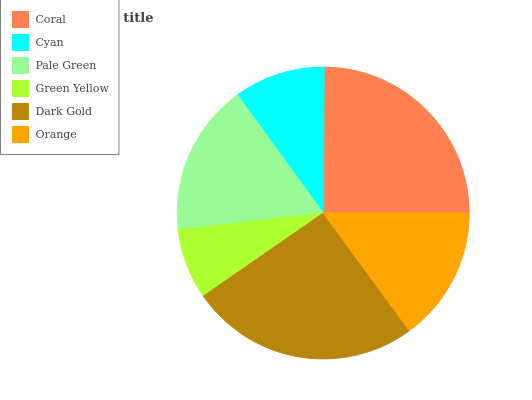Is Green Yellow the minimum?
Answer yes or no. Yes. Is Dark Gold the maximum?
Answer yes or no. Yes. Is Cyan the minimum?
Answer yes or no. No. Is Cyan the maximum?
Answer yes or no. No. Is Coral greater than Cyan?
Answer yes or no. Yes. Is Cyan less than Coral?
Answer yes or no. Yes. Is Cyan greater than Coral?
Answer yes or no. No. Is Coral less than Cyan?
Answer yes or no. No. Is Pale Green the high median?
Answer yes or no. Yes. Is Orange the low median?
Answer yes or no. Yes. Is Coral the high median?
Answer yes or no. No. Is Pale Green the low median?
Answer yes or no. No. 